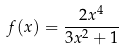Convert formula to latex. <formula><loc_0><loc_0><loc_500><loc_500>f ( x ) = \frac { 2 x ^ { 4 } } { 3 x ^ { 2 } + 1 }</formula> 